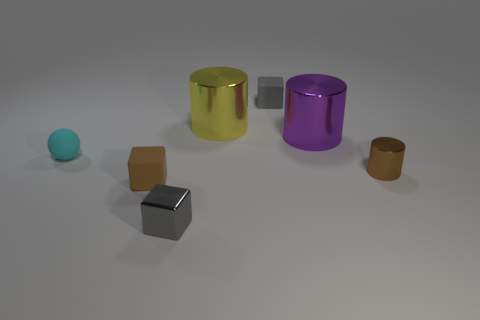What number of other objects are there of the same color as the tiny metal cylinder?
Your response must be concise. 1. What number of big purple shiny things are the same shape as the yellow shiny object?
Give a very brief answer. 1. What color is the small matte cube that is on the right side of the tiny gray cube on the left side of the matte object behind the small rubber sphere?
Your answer should be very brief. Gray. Are the tiny gray object behind the tiny brown rubber object and the small brown object that is behind the small brown block made of the same material?
Provide a succinct answer. No. How many things are big shiny things that are left of the big purple cylinder or cyan things?
Provide a succinct answer. 2. What number of things are either tiny red metallic blocks or gray things behind the cyan ball?
Ensure brevity in your answer.  1. What number of brown metal balls are the same size as the brown metallic object?
Provide a short and direct response. 0. Is the number of yellow metallic objects that are to the right of the purple metal cylinder less than the number of tiny brown cubes that are on the right side of the tiny brown cylinder?
Make the answer very short. No. How many rubber things are big yellow cylinders or yellow cubes?
Keep it short and to the point. 0. What is the shape of the brown rubber object?
Give a very brief answer. Cube. 